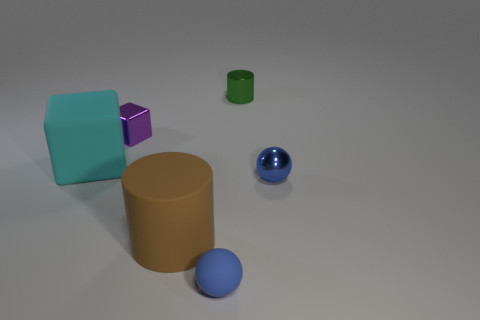There is a small blue object behind the cylinder in front of the metal object that is in front of the purple metallic object; what is its material?
Keep it short and to the point. Metal. Are there more shiny cubes in front of the cyan rubber thing than blue metal balls that are right of the small blue shiny thing?
Keep it short and to the point. No. What number of metal objects are big blue things or cyan blocks?
Your answer should be compact. 0. There is a object that is the same color as the small matte ball; what is its shape?
Give a very brief answer. Sphere. What is the tiny sphere that is left of the metal cylinder made of?
Make the answer very short. Rubber. What number of things are either cyan rubber blocks or small metallic things in front of the green metallic cylinder?
Your response must be concise. 3. There is another thing that is the same size as the brown matte thing; what shape is it?
Provide a short and direct response. Cube. What number of big things are the same color as the big block?
Make the answer very short. 0. Are the tiny blue ball right of the small green thing and the cyan thing made of the same material?
Ensure brevity in your answer.  No. The small purple metallic thing is what shape?
Provide a succinct answer. Cube. 